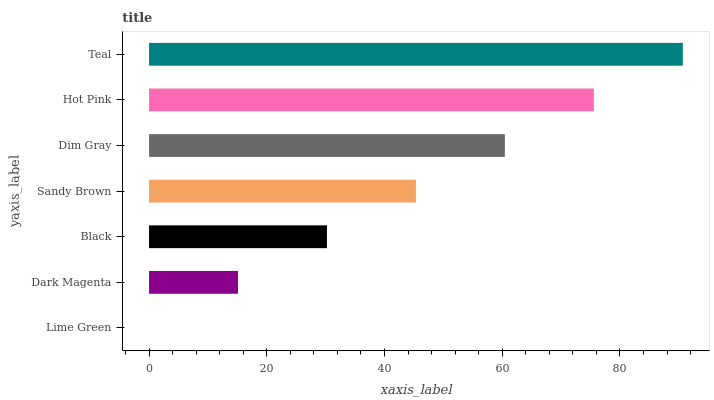Is Lime Green the minimum?
Answer yes or no. Yes. Is Teal the maximum?
Answer yes or no. Yes. Is Dark Magenta the minimum?
Answer yes or no. No. Is Dark Magenta the maximum?
Answer yes or no. No. Is Dark Magenta greater than Lime Green?
Answer yes or no. Yes. Is Lime Green less than Dark Magenta?
Answer yes or no. Yes. Is Lime Green greater than Dark Magenta?
Answer yes or no. No. Is Dark Magenta less than Lime Green?
Answer yes or no. No. Is Sandy Brown the high median?
Answer yes or no. Yes. Is Sandy Brown the low median?
Answer yes or no. Yes. Is Dark Magenta the high median?
Answer yes or no. No. Is Hot Pink the low median?
Answer yes or no. No. 